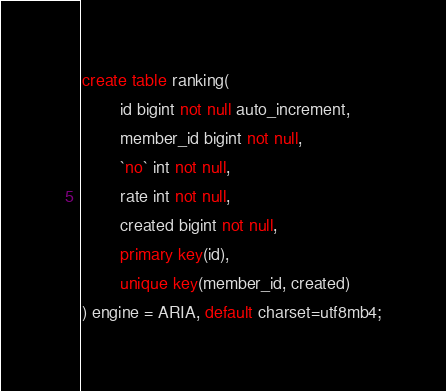Convert code to text. <code><loc_0><loc_0><loc_500><loc_500><_SQL_>
create table ranking(
        id bigint not null auto_increment,
        member_id bigint not null,
        `no` int not null,
        rate int not null,
        created bigint not null,
        primary key(id),
        unique key(member_id, created)
) engine = ARIA, default charset=utf8mb4;
</code> 